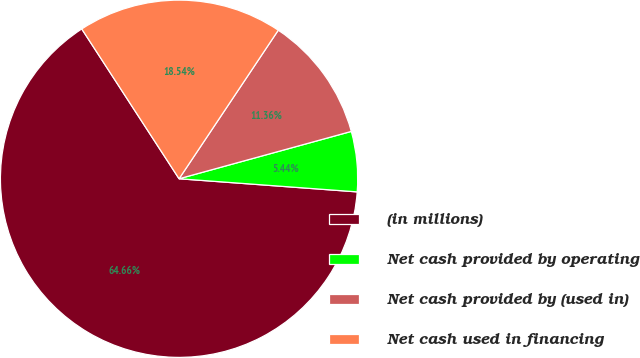Convert chart to OTSL. <chart><loc_0><loc_0><loc_500><loc_500><pie_chart><fcel>(in millions)<fcel>Net cash provided by operating<fcel>Net cash provided by (used in)<fcel>Net cash used in financing<nl><fcel>64.66%<fcel>5.44%<fcel>11.36%<fcel>18.54%<nl></chart> 